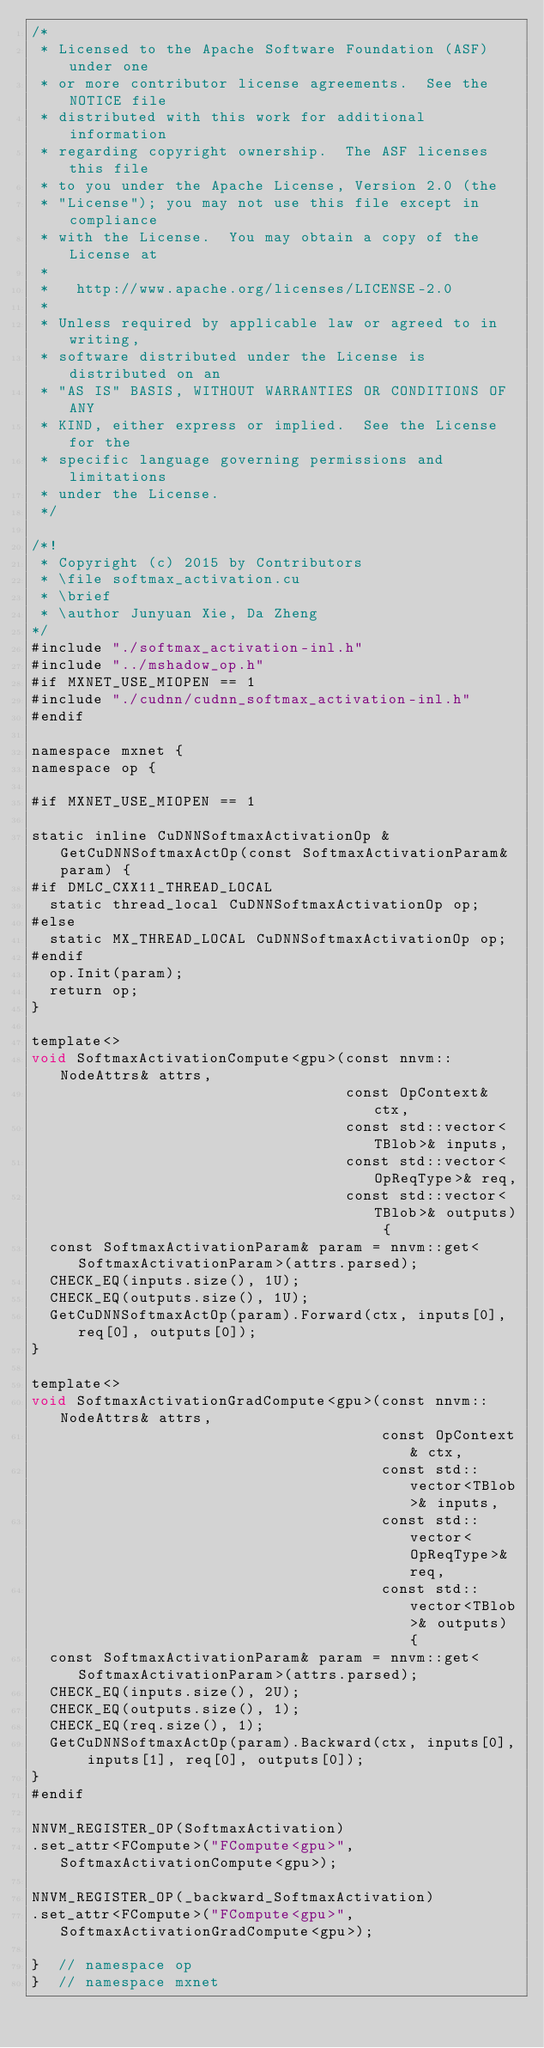Convert code to text. <code><loc_0><loc_0><loc_500><loc_500><_Cuda_>/*
 * Licensed to the Apache Software Foundation (ASF) under one
 * or more contributor license agreements.  See the NOTICE file
 * distributed with this work for additional information
 * regarding copyright ownership.  The ASF licenses this file
 * to you under the Apache License, Version 2.0 (the
 * "License"); you may not use this file except in compliance
 * with the License.  You may obtain a copy of the License at
 *
 *   http://www.apache.org/licenses/LICENSE-2.0
 *
 * Unless required by applicable law or agreed to in writing,
 * software distributed under the License is distributed on an
 * "AS IS" BASIS, WITHOUT WARRANTIES OR CONDITIONS OF ANY
 * KIND, either express or implied.  See the License for the
 * specific language governing permissions and limitations
 * under the License.
 */

/*!
 * Copyright (c) 2015 by Contributors
 * \file softmax_activation.cu
 * \brief
 * \author Junyuan Xie, Da Zheng
*/
#include "./softmax_activation-inl.h"
#include "../mshadow_op.h"
#if MXNET_USE_MIOPEN == 1
#include "./cudnn/cudnn_softmax_activation-inl.h"
#endif

namespace mxnet {
namespace op {

#if MXNET_USE_MIOPEN == 1

static inline CuDNNSoftmaxActivationOp &GetCuDNNSoftmaxActOp(const SoftmaxActivationParam& param) {
#if DMLC_CXX11_THREAD_LOCAL
  static thread_local CuDNNSoftmaxActivationOp op;
#else
  static MX_THREAD_LOCAL CuDNNSoftmaxActivationOp op;
#endif
  op.Init(param);
  return op;
}

template<>
void SoftmaxActivationCompute<gpu>(const nnvm::NodeAttrs& attrs,
                                   const OpContext& ctx,
                                   const std::vector<TBlob>& inputs,
                                   const std::vector<OpReqType>& req,
                                   const std::vector<TBlob>& outputs) {
  const SoftmaxActivationParam& param = nnvm::get<SoftmaxActivationParam>(attrs.parsed);
  CHECK_EQ(inputs.size(), 1U);
  CHECK_EQ(outputs.size(), 1U);
  GetCuDNNSoftmaxActOp(param).Forward(ctx, inputs[0], req[0], outputs[0]);
}

template<>
void SoftmaxActivationGradCompute<gpu>(const nnvm::NodeAttrs& attrs,
                                       const OpContext& ctx,
                                       const std::vector<TBlob>& inputs,
                                       const std::vector<OpReqType>& req,
                                       const std::vector<TBlob>& outputs) {
  const SoftmaxActivationParam& param = nnvm::get<SoftmaxActivationParam>(attrs.parsed);
  CHECK_EQ(inputs.size(), 2U);
  CHECK_EQ(outputs.size(), 1);
  CHECK_EQ(req.size(), 1);
  GetCuDNNSoftmaxActOp(param).Backward(ctx, inputs[0], inputs[1], req[0], outputs[0]);
}
#endif

NNVM_REGISTER_OP(SoftmaxActivation)
.set_attr<FCompute>("FCompute<gpu>", SoftmaxActivationCompute<gpu>);

NNVM_REGISTER_OP(_backward_SoftmaxActivation)
.set_attr<FCompute>("FCompute<gpu>", SoftmaxActivationGradCompute<gpu>);

}  // namespace op
}  // namespace mxnet

</code> 